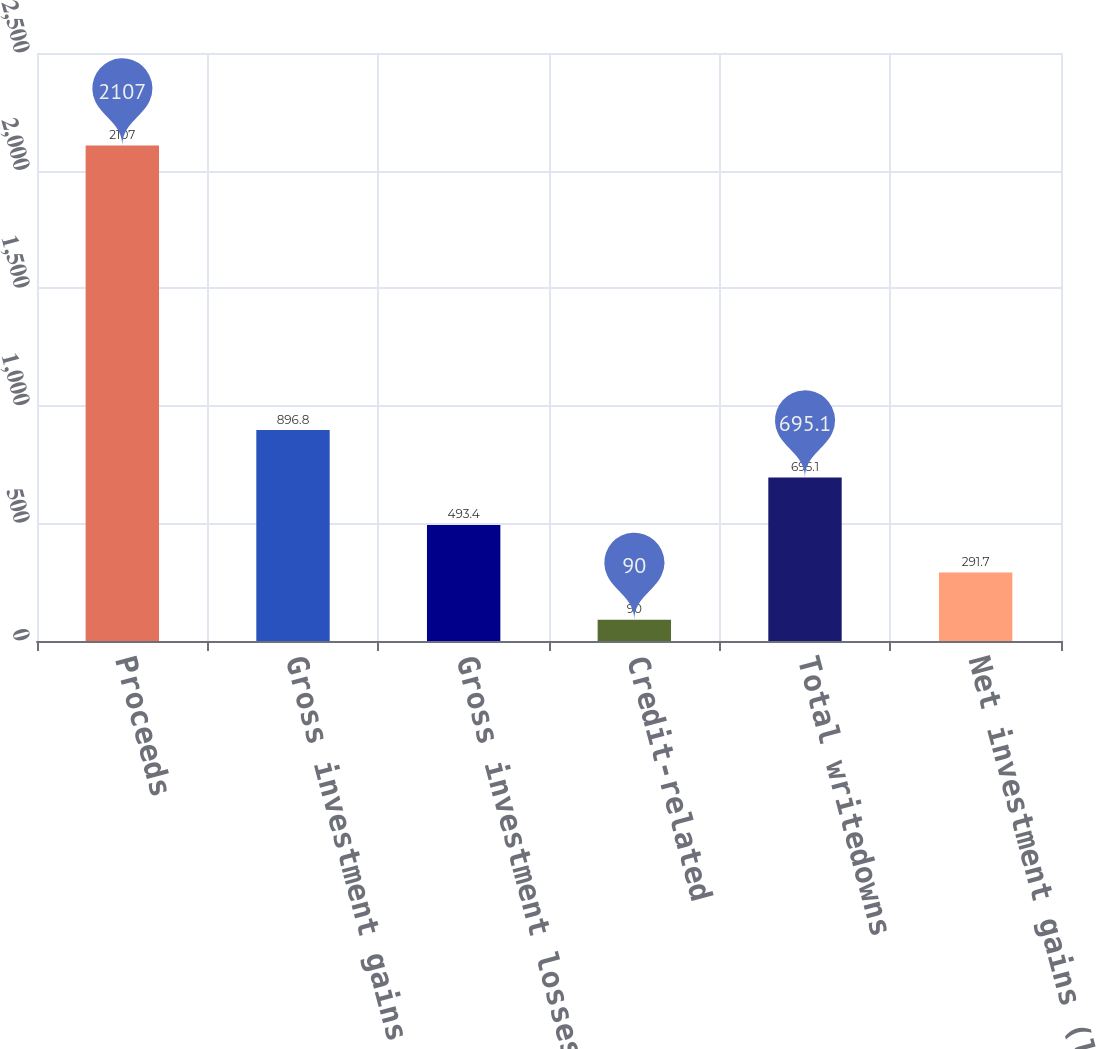<chart> <loc_0><loc_0><loc_500><loc_500><bar_chart><fcel>Proceeds<fcel>Gross investment gains<fcel>Gross investment losses<fcel>Credit-related<fcel>Total writedowns<fcel>Net investment gains (losses)<nl><fcel>2107<fcel>896.8<fcel>493.4<fcel>90<fcel>695.1<fcel>291.7<nl></chart> 